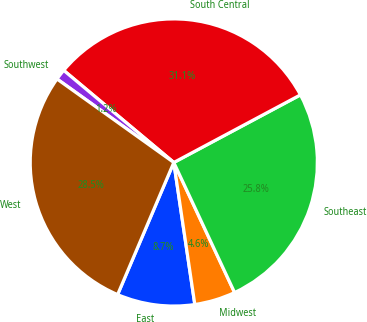<chart> <loc_0><loc_0><loc_500><loc_500><pie_chart><fcel>East<fcel>Midwest<fcel>Southeast<fcel>South Central<fcel>Southwest<fcel>West<nl><fcel>8.74%<fcel>4.62%<fcel>25.85%<fcel>31.11%<fcel>1.21%<fcel>28.48%<nl></chart> 